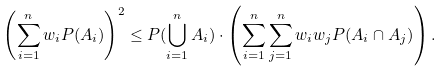Convert formula to latex. <formula><loc_0><loc_0><loc_500><loc_500>\left ( \sum _ { i = 1 } ^ { n } w _ { i } P ( A _ { i } ) \right ) ^ { 2 } \leq P ( \bigcup _ { i = 1 } ^ { n } A _ { i } ) \cdot \left ( \sum _ { i = 1 } ^ { n } \sum _ { j = 1 } ^ { n } { w _ { i } w _ { j } { P } ( A _ { i } \cap A _ { j } ) } \right ) .</formula> 